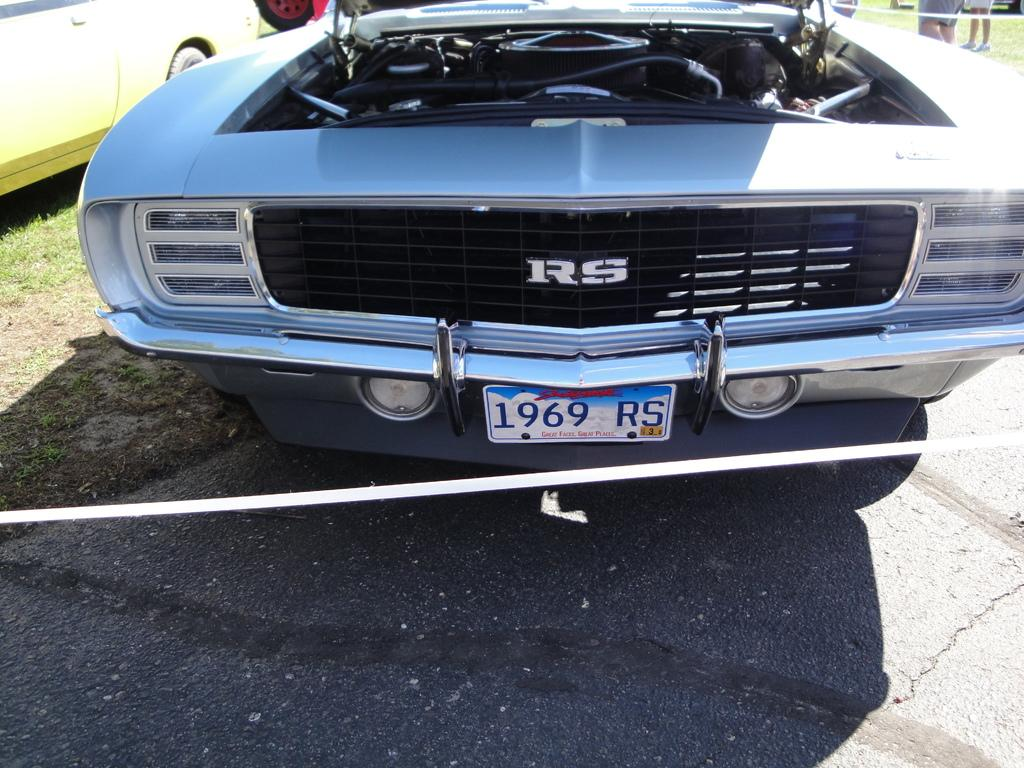What types of objects can be seen in the image? There are vehicles in the image. Can you describe the setting where the vehicles are located? There are people standing on the grass in the background of the image. What type of fruit is growing in the stomach of the person in the image? There is no person with a stomach visible in the image, and therefore no fruit can be observed growing in it. 